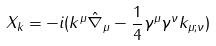Convert formula to latex. <formula><loc_0><loc_0><loc_500><loc_500>X _ { k } = - i ( k ^ { \mu } \hat { \nabla } _ { \mu } - { \frac { 1 } { 4 } } \gamma ^ { \mu } \gamma ^ { \nu } k _ { \mu ; \nu } )</formula> 